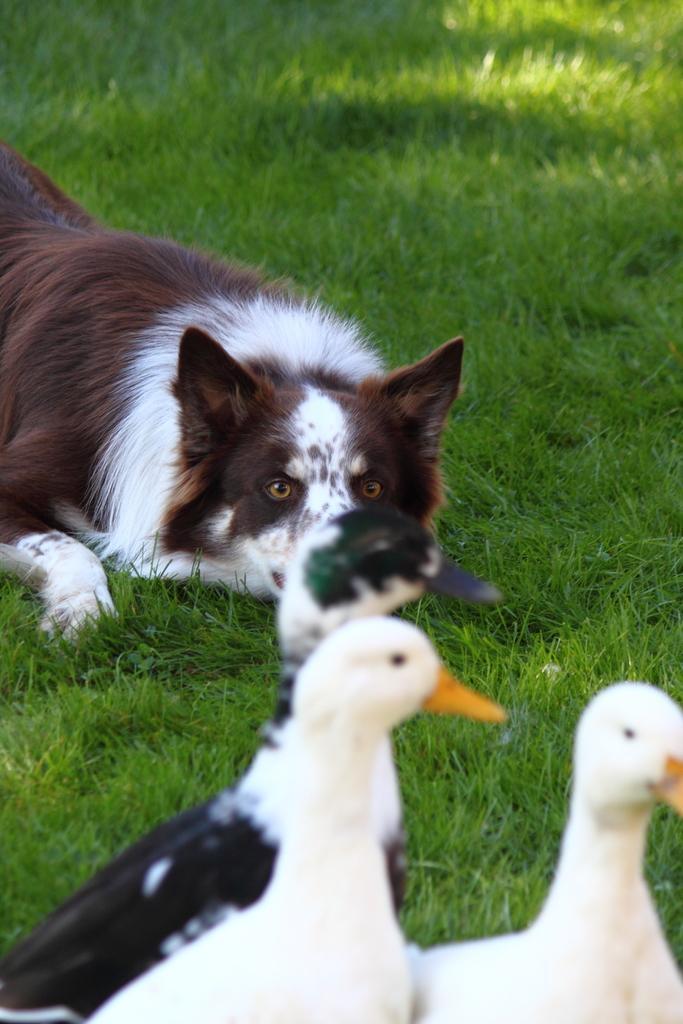Describe this image in one or two sentences. In this picture we can see a dog, who is lying on the grass. On the bottom there are three ducks and one of the duck is in black color and two of them are in white color. 